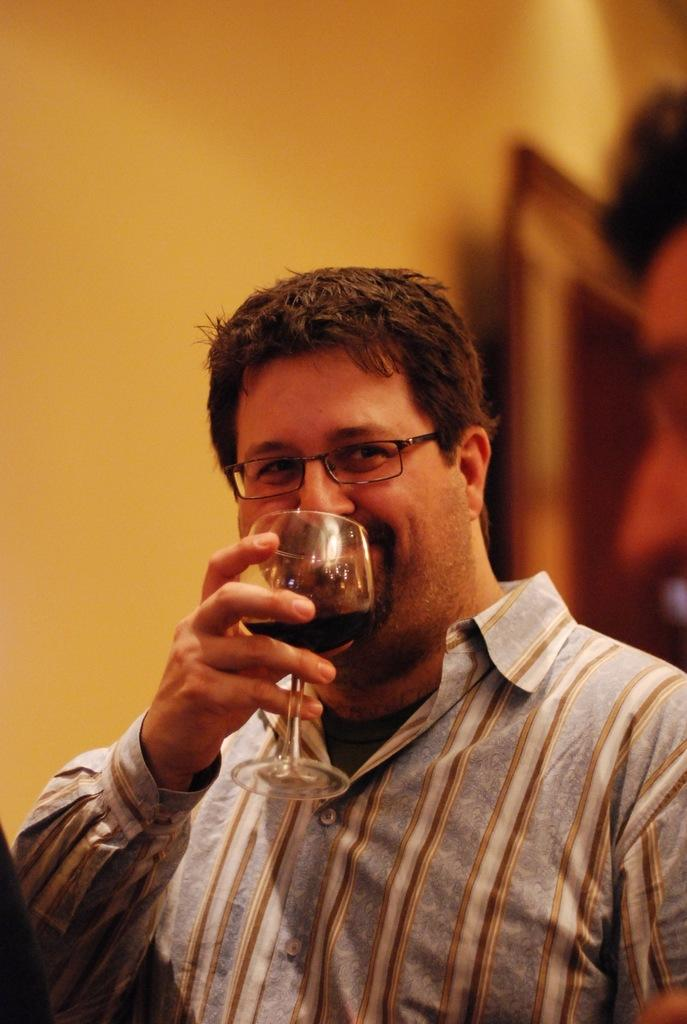Who is present in the image? There is a man in the image. What is the man wearing? The man is wearing spectacles. What is the man holding in the image? The man is holding a glass with a drink in it. What is the man's facial expression? The man is smiling. What type of leather is covering the zebra in the image? There is no zebra or leather present in the image; it features a man holding a glass with a drink in it. 